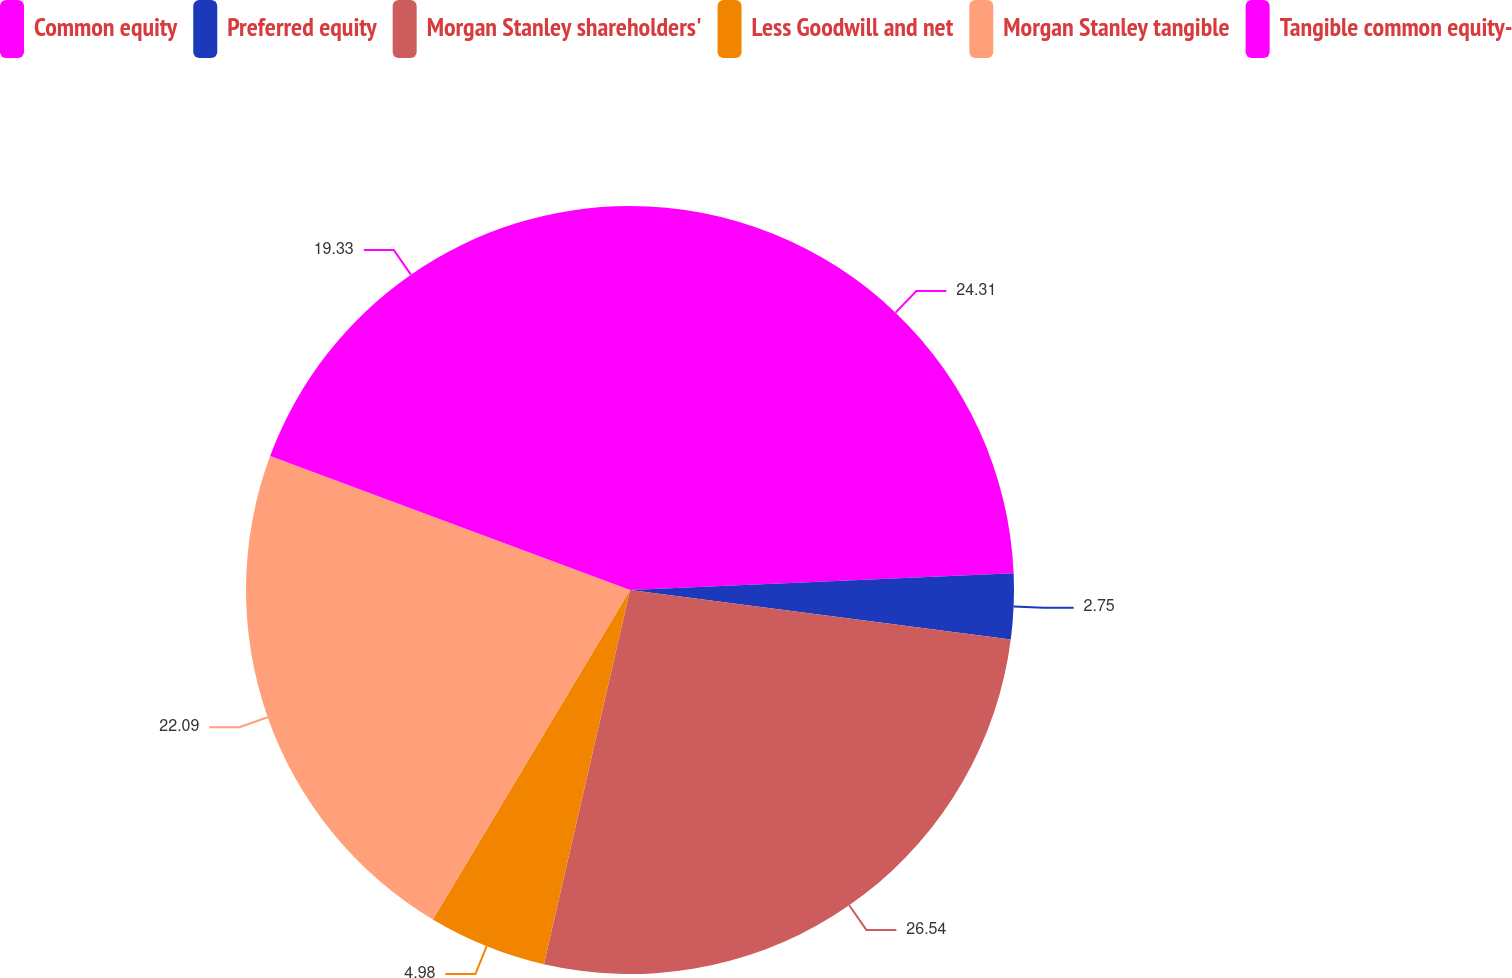Convert chart to OTSL. <chart><loc_0><loc_0><loc_500><loc_500><pie_chart><fcel>Common equity<fcel>Preferred equity<fcel>Morgan Stanley shareholders'<fcel>Less Goodwill and net<fcel>Morgan Stanley tangible<fcel>Tangible common equity-<nl><fcel>24.31%<fcel>2.75%<fcel>26.54%<fcel>4.98%<fcel>22.09%<fcel>19.33%<nl></chart> 